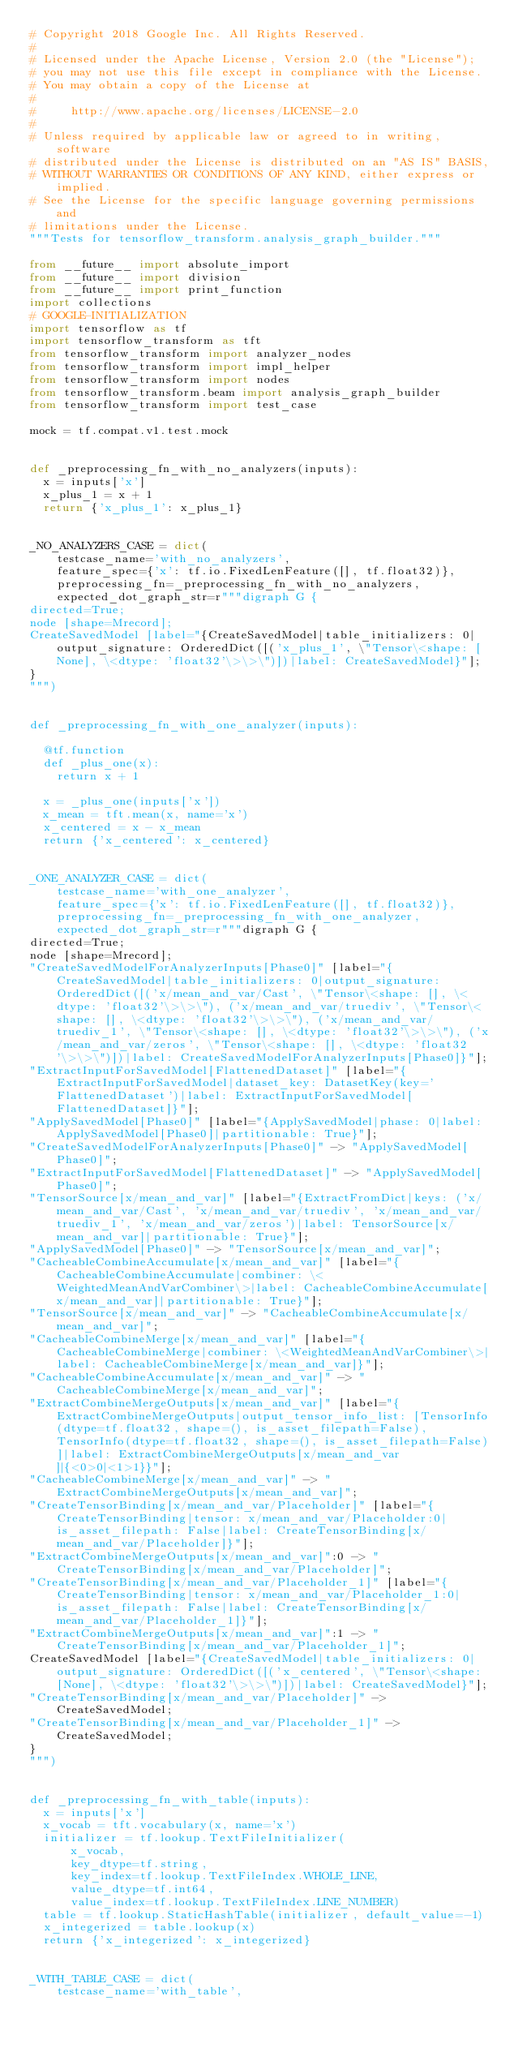<code> <loc_0><loc_0><loc_500><loc_500><_Python_># Copyright 2018 Google Inc. All Rights Reserved.
#
# Licensed under the Apache License, Version 2.0 (the "License");
# you may not use this file except in compliance with the License.
# You may obtain a copy of the License at
#
#     http://www.apache.org/licenses/LICENSE-2.0
#
# Unless required by applicable law or agreed to in writing, software
# distributed under the License is distributed on an "AS IS" BASIS,
# WITHOUT WARRANTIES OR CONDITIONS OF ANY KIND, either express or implied.
# See the License for the specific language governing permissions and
# limitations under the License.
"""Tests for tensorflow_transform.analysis_graph_builder."""

from __future__ import absolute_import
from __future__ import division
from __future__ import print_function
import collections
# GOOGLE-INITIALIZATION
import tensorflow as tf
import tensorflow_transform as tft
from tensorflow_transform import analyzer_nodes
from tensorflow_transform import impl_helper
from tensorflow_transform import nodes
from tensorflow_transform.beam import analysis_graph_builder
from tensorflow_transform import test_case

mock = tf.compat.v1.test.mock


def _preprocessing_fn_with_no_analyzers(inputs):
  x = inputs['x']
  x_plus_1 = x + 1
  return {'x_plus_1': x_plus_1}


_NO_ANALYZERS_CASE = dict(
    testcase_name='with_no_analyzers',
    feature_spec={'x': tf.io.FixedLenFeature([], tf.float32)},
    preprocessing_fn=_preprocessing_fn_with_no_analyzers,
    expected_dot_graph_str=r"""digraph G {
directed=True;
node [shape=Mrecord];
CreateSavedModel [label="{CreateSavedModel|table_initializers: 0|output_signature: OrderedDict([('x_plus_1', \"Tensor\<shape: [None], \<dtype: 'float32'\>\>\")])|label: CreateSavedModel}"];
}
""")


def _preprocessing_fn_with_one_analyzer(inputs):

  @tf.function
  def _plus_one(x):
    return x + 1

  x = _plus_one(inputs['x'])
  x_mean = tft.mean(x, name='x')
  x_centered = x - x_mean
  return {'x_centered': x_centered}


_ONE_ANALYZER_CASE = dict(
    testcase_name='with_one_analyzer',
    feature_spec={'x': tf.io.FixedLenFeature([], tf.float32)},
    preprocessing_fn=_preprocessing_fn_with_one_analyzer,
    expected_dot_graph_str=r"""digraph G {
directed=True;
node [shape=Mrecord];
"CreateSavedModelForAnalyzerInputs[Phase0]" [label="{CreateSavedModel|table_initializers: 0|output_signature: OrderedDict([('x/mean_and_var/Cast', \"Tensor\<shape: [], \<dtype: 'float32'\>\>\"), ('x/mean_and_var/truediv', \"Tensor\<shape: [], \<dtype: 'float32'\>\>\"), ('x/mean_and_var/truediv_1', \"Tensor\<shape: [], \<dtype: 'float32'\>\>\"), ('x/mean_and_var/zeros', \"Tensor\<shape: [], \<dtype: 'float32'\>\>\")])|label: CreateSavedModelForAnalyzerInputs[Phase0]}"];
"ExtractInputForSavedModel[FlattenedDataset]" [label="{ExtractInputForSavedModel|dataset_key: DatasetKey(key='FlattenedDataset')|label: ExtractInputForSavedModel[FlattenedDataset]}"];
"ApplySavedModel[Phase0]" [label="{ApplySavedModel|phase: 0|label: ApplySavedModel[Phase0]|partitionable: True}"];
"CreateSavedModelForAnalyzerInputs[Phase0]" -> "ApplySavedModel[Phase0]";
"ExtractInputForSavedModel[FlattenedDataset]" -> "ApplySavedModel[Phase0]";
"TensorSource[x/mean_and_var]" [label="{ExtractFromDict|keys: ('x/mean_and_var/Cast', 'x/mean_and_var/truediv', 'x/mean_and_var/truediv_1', 'x/mean_and_var/zeros')|label: TensorSource[x/mean_and_var]|partitionable: True}"];
"ApplySavedModel[Phase0]" -> "TensorSource[x/mean_and_var]";
"CacheableCombineAccumulate[x/mean_and_var]" [label="{CacheableCombineAccumulate|combiner: \<WeightedMeanAndVarCombiner\>|label: CacheableCombineAccumulate[x/mean_and_var]|partitionable: True}"];
"TensorSource[x/mean_and_var]" -> "CacheableCombineAccumulate[x/mean_and_var]";
"CacheableCombineMerge[x/mean_and_var]" [label="{CacheableCombineMerge|combiner: \<WeightedMeanAndVarCombiner\>|label: CacheableCombineMerge[x/mean_and_var]}"];
"CacheableCombineAccumulate[x/mean_and_var]" -> "CacheableCombineMerge[x/mean_and_var]";
"ExtractCombineMergeOutputs[x/mean_and_var]" [label="{ExtractCombineMergeOutputs|output_tensor_info_list: [TensorInfo(dtype=tf.float32, shape=(), is_asset_filepath=False), TensorInfo(dtype=tf.float32, shape=(), is_asset_filepath=False)]|label: ExtractCombineMergeOutputs[x/mean_and_var]|{<0>0|<1>1}}"];
"CacheableCombineMerge[x/mean_and_var]" -> "ExtractCombineMergeOutputs[x/mean_and_var]";
"CreateTensorBinding[x/mean_and_var/Placeholder]" [label="{CreateTensorBinding|tensor: x/mean_and_var/Placeholder:0|is_asset_filepath: False|label: CreateTensorBinding[x/mean_and_var/Placeholder]}"];
"ExtractCombineMergeOutputs[x/mean_and_var]":0 -> "CreateTensorBinding[x/mean_and_var/Placeholder]";
"CreateTensorBinding[x/mean_and_var/Placeholder_1]" [label="{CreateTensorBinding|tensor: x/mean_and_var/Placeholder_1:0|is_asset_filepath: False|label: CreateTensorBinding[x/mean_and_var/Placeholder_1]}"];
"ExtractCombineMergeOutputs[x/mean_and_var]":1 -> "CreateTensorBinding[x/mean_and_var/Placeholder_1]";
CreateSavedModel [label="{CreateSavedModel|table_initializers: 0|output_signature: OrderedDict([('x_centered', \"Tensor\<shape: [None], \<dtype: 'float32'\>\>\")])|label: CreateSavedModel}"];
"CreateTensorBinding[x/mean_and_var/Placeholder]" -> CreateSavedModel;
"CreateTensorBinding[x/mean_and_var/Placeholder_1]" -> CreateSavedModel;
}
""")


def _preprocessing_fn_with_table(inputs):
  x = inputs['x']
  x_vocab = tft.vocabulary(x, name='x')
  initializer = tf.lookup.TextFileInitializer(
      x_vocab,
      key_dtype=tf.string,
      key_index=tf.lookup.TextFileIndex.WHOLE_LINE,
      value_dtype=tf.int64,
      value_index=tf.lookup.TextFileIndex.LINE_NUMBER)
  table = tf.lookup.StaticHashTable(initializer, default_value=-1)
  x_integerized = table.lookup(x)
  return {'x_integerized': x_integerized}


_WITH_TABLE_CASE = dict(
    testcase_name='with_table',</code> 